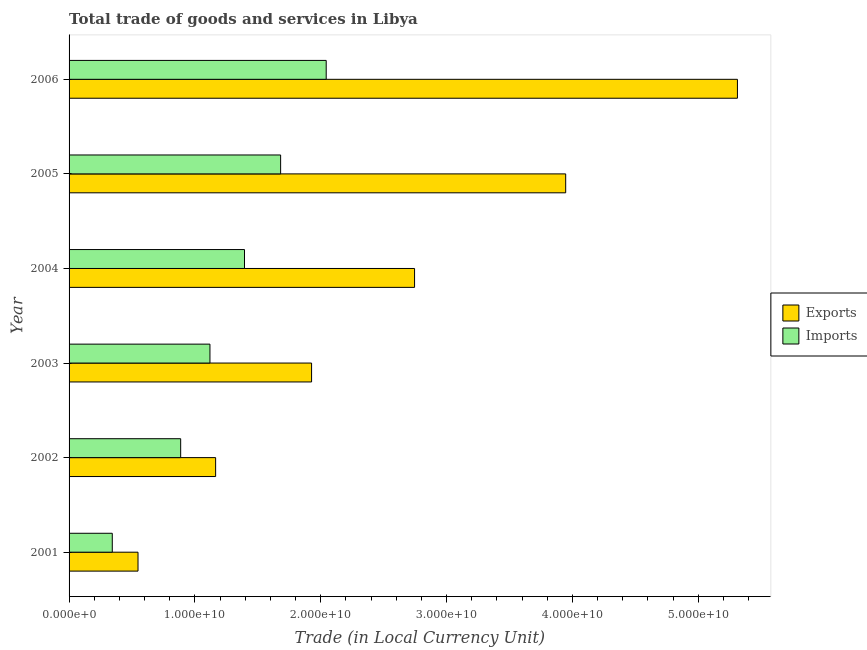How many different coloured bars are there?
Give a very brief answer. 2. Are the number of bars per tick equal to the number of legend labels?
Provide a succinct answer. Yes. How many bars are there on the 4th tick from the top?
Ensure brevity in your answer.  2. What is the label of the 1st group of bars from the top?
Keep it short and to the point. 2006. In how many cases, is the number of bars for a given year not equal to the number of legend labels?
Your response must be concise. 0. What is the export of goods and services in 2005?
Ensure brevity in your answer.  3.95e+1. Across all years, what is the maximum imports of goods and services?
Your response must be concise. 2.04e+1. Across all years, what is the minimum export of goods and services?
Make the answer very short. 5.48e+09. In which year was the imports of goods and services minimum?
Ensure brevity in your answer.  2001. What is the total export of goods and services in the graph?
Give a very brief answer. 1.56e+11. What is the difference between the export of goods and services in 2001 and that in 2006?
Provide a succinct answer. -4.76e+1. What is the difference between the imports of goods and services in 2006 and the export of goods and services in 2001?
Make the answer very short. 1.50e+1. What is the average export of goods and services per year?
Your answer should be compact. 2.61e+1. In the year 2004, what is the difference between the export of goods and services and imports of goods and services?
Provide a succinct answer. 1.35e+1. What is the ratio of the export of goods and services in 2001 to that in 2004?
Keep it short and to the point. 0.2. Is the export of goods and services in 2003 less than that in 2005?
Ensure brevity in your answer.  Yes. Is the difference between the imports of goods and services in 2003 and 2006 greater than the difference between the export of goods and services in 2003 and 2006?
Give a very brief answer. Yes. What is the difference between the highest and the second highest imports of goods and services?
Ensure brevity in your answer.  3.62e+09. What is the difference between the highest and the lowest export of goods and services?
Provide a succinct answer. 4.76e+1. Is the sum of the imports of goods and services in 2002 and 2003 greater than the maximum export of goods and services across all years?
Keep it short and to the point. No. What does the 2nd bar from the top in 2002 represents?
Provide a succinct answer. Exports. What does the 2nd bar from the bottom in 2002 represents?
Your answer should be very brief. Imports. How many years are there in the graph?
Provide a short and direct response. 6. Are the values on the major ticks of X-axis written in scientific E-notation?
Offer a very short reply. Yes. Does the graph contain any zero values?
Your answer should be very brief. No. Where does the legend appear in the graph?
Your response must be concise. Center right. How many legend labels are there?
Your answer should be very brief. 2. What is the title of the graph?
Ensure brevity in your answer.  Total trade of goods and services in Libya. Does "Males" appear as one of the legend labels in the graph?
Make the answer very short. No. What is the label or title of the X-axis?
Your answer should be very brief. Trade (in Local Currency Unit). What is the label or title of the Y-axis?
Provide a succinct answer. Year. What is the Trade (in Local Currency Unit) of Exports in 2001?
Make the answer very short. 5.48e+09. What is the Trade (in Local Currency Unit) in Imports in 2001?
Ensure brevity in your answer.  3.43e+09. What is the Trade (in Local Currency Unit) of Exports in 2002?
Keep it short and to the point. 1.16e+1. What is the Trade (in Local Currency Unit) of Imports in 2002?
Make the answer very short. 8.87e+09. What is the Trade (in Local Currency Unit) of Exports in 2003?
Ensure brevity in your answer.  1.93e+1. What is the Trade (in Local Currency Unit) of Imports in 2003?
Ensure brevity in your answer.  1.12e+1. What is the Trade (in Local Currency Unit) in Exports in 2004?
Your answer should be very brief. 2.75e+1. What is the Trade (in Local Currency Unit) of Imports in 2004?
Make the answer very short. 1.39e+1. What is the Trade (in Local Currency Unit) of Exports in 2005?
Keep it short and to the point. 3.95e+1. What is the Trade (in Local Currency Unit) in Imports in 2005?
Your answer should be very brief. 1.68e+1. What is the Trade (in Local Currency Unit) in Exports in 2006?
Your answer should be compact. 5.31e+1. What is the Trade (in Local Currency Unit) in Imports in 2006?
Your answer should be compact. 2.04e+1. Across all years, what is the maximum Trade (in Local Currency Unit) of Exports?
Keep it short and to the point. 5.31e+1. Across all years, what is the maximum Trade (in Local Currency Unit) in Imports?
Give a very brief answer. 2.04e+1. Across all years, what is the minimum Trade (in Local Currency Unit) in Exports?
Keep it short and to the point. 5.48e+09. Across all years, what is the minimum Trade (in Local Currency Unit) in Imports?
Your response must be concise. 3.43e+09. What is the total Trade (in Local Currency Unit) in Exports in the graph?
Provide a short and direct response. 1.56e+11. What is the total Trade (in Local Currency Unit) of Imports in the graph?
Give a very brief answer. 7.47e+1. What is the difference between the Trade (in Local Currency Unit) of Exports in 2001 and that in 2002?
Make the answer very short. -6.17e+09. What is the difference between the Trade (in Local Currency Unit) of Imports in 2001 and that in 2002?
Your response must be concise. -5.44e+09. What is the difference between the Trade (in Local Currency Unit) in Exports in 2001 and that in 2003?
Offer a very short reply. -1.38e+1. What is the difference between the Trade (in Local Currency Unit) of Imports in 2001 and that in 2003?
Ensure brevity in your answer.  -7.76e+09. What is the difference between the Trade (in Local Currency Unit) in Exports in 2001 and that in 2004?
Provide a short and direct response. -2.20e+1. What is the difference between the Trade (in Local Currency Unit) of Imports in 2001 and that in 2004?
Give a very brief answer. -1.05e+1. What is the difference between the Trade (in Local Currency Unit) in Exports in 2001 and that in 2005?
Ensure brevity in your answer.  -3.40e+1. What is the difference between the Trade (in Local Currency Unit) of Imports in 2001 and that in 2005?
Your answer should be compact. -1.34e+1. What is the difference between the Trade (in Local Currency Unit) in Exports in 2001 and that in 2006?
Your answer should be compact. -4.76e+1. What is the difference between the Trade (in Local Currency Unit) of Imports in 2001 and that in 2006?
Your answer should be compact. -1.70e+1. What is the difference between the Trade (in Local Currency Unit) of Exports in 2002 and that in 2003?
Keep it short and to the point. -7.62e+09. What is the difference between the Trade (in Local Currency Unit) of Imports in 2002 and that in 2003?
Offer a very short reply. -2.33e+09. What is the difference between the Trade (in Local Currency Unit) in Exports in 2002 and that in 2004?
Ensure brevity in your answer.  -1.58e+1. What is the difference between the Trade (in Local Currency Unit) in Imports in 2002 and that in 2004?
Offer a terse response. -5.07e+09. What is the difference between the Trade (in Local Currency Unit) in Exports in 2002 and that in 2005?
Offer a very short reply. -2.78e+1. What is the difference between the Trade (in Local Currency Unit) of Imports in 2002 and that in 2005?
Your answer should be compact. -7.94e+09. What is the difference between the Trade (in Local Currency Unit) of Exports in 2002 and that in 2006?
Your answer should be compact. -4.15e+1. What is the difference between the Trade (in Local Currency Unit) in Imports in 2002 and that in 2006?
Provide a short and direct response. -1.16e+1. What is the difference between the Trade (in Local Currency Unit) of Exports in 2003 and that in 2004?
Give a very brief answer. -8.18e+09. What is the difference between the Trade (in Local Currency Unit) of Imports in 2003 and that in 2004?
Provide a succinct answer. -2.75e+09. What is the difference between the Trade (in Local Currency Unit) of Exports in 2003 and that in 2005?
Offer a very short reply. -2.02e+1. What is the difference between the Trade (in Local Currency Unit) in Imports in 2003 and that in 2005?
Ensure brevity in your answer.  -5.62e+09. What is the difference between the Trade (in Local Currency Unit) in Exports in 2003 and that in 2006?
Your response must be concise. -3.38e+1. What is the difference between the Trade (in Local Currency Unit) in Imports in 2003 and that in 2006?
Give a very brief answer. -9.24e+09. What is the difference between the Trade (in Local Currency Unit) of Exports in 2004 and that in 2005?
Offer a very short reply. -1.20e+1. What is the difference between the Trade (in Local Currency Unit) of Imports in 2004 and that in 2005?
Keep it short and to the point. -2.87e+09. What is the difference between the Trade (in Local Currency Unit) in Exports in 2004 and that in 2006?
Provide a succinct answer. -2.57e+1. What is the difference between the Trade (in Local Currency Unit) of Imports in 2004 and that in 2006?
Make the answer very short. -6.49e+09. What is the difference between the Trade (in Local Currency Unit) in Exports in 2005 and that in 2006?
Your response must be concise. -1.36e+1. What is the difference between the Trade (in Local Currency Unit) in Imports in 2005 and that in 2006?
Provide a short and direct response. -3.62e+09. What is the difference between the Trade (in Local Currency Unit) of Exports in 2001 and the Trade (in Local Currency Unit) of Imports in 2002?
Make the answer very short. -3.39e+09. What is the difference between the Trade (in Local Currency Unit) of Exports in 2001 and the Trade (in Local Currency Unit) of Imports in 2003?
Provide a short and direct response. -5.72e+09. What is the difference between the Trade (in Local Currency Unit) of Exports in 2001 and the Trade (in Local Currency Unit) of Imports in 2004?
Your answer should be compact. -8.46e+09. What is the difference between the Trade (in Local Currency Unit) of Exports in 2001 and the Trade (in Local Currency Unit) of Imports in 2005?
Provide a succinct answer. -1.13e+1. What is the difference between the Trade (in Local Currency Unit) in Exports in 2001 and the Trade (in Local Currency Unit) in Imports in 2006?
Keep it short and to the point. -1.50e+1. What is the difference between the Trade (in Local Currency Unit) of Exports in 2002 and the Trade (in Local Currency Unit) of Imports in 2003?
Your response must be concise. 4.51e+08. What is the difference between the Trade (in Local Currency Unit) of Exports in 2002 and the Trade (in Local Currency Unit) of Imports in 2004?
Provide a succinct answer. -2.29e+09. What is the difference between the Trade (in Local Currency Unit) of Exports in 2002 and the Trade (in Local Currency Unit) of Imports in 2005?
Ensure brevity in your answer.  -5.17e+09. What is the difference between the Trade (in Local Currency Unit) of Exports in 2002 and the Trade (in Local Currency Unit) of Imports in 2006?
Your response must be concise. -8.79e+09. What is the difference between the Trade (in Local Currency Unit) in Exports in 2003 and the Trade (in Local Currency Unit) in Imports in 2004?
Keep it short and to the point. 5.33e+09. What is the difference between the Trade (in Local Currency Unit) in Exports in 2003 and the Trade (in Local Currency Unit) in Imports in 2005?
Your response must be concise. 2.46e+09. What is the difference between the Trade (in Local Currency Unit) in Exports in 2003 and the Trade (in Local Currency Unit) in Imports in 2006?
Offer a very short reply. -1.16e+09. What is the difference between the Trade (in Local Currency Unit) in Exports in 2004 and the Trade (in Local Currency Unit) in Imports in 2005?
Your answer should be compact. 1.06e+1. What is the difference between the Trade (in Local Currency Unit) in Exports in 2004 and the Trade (in Local Currency Unit) in Imports in 2006?
Provide a short and direct response. 7.02e+09. What is the difference between the Trade (in Local Currency Unit) of Exports in 2005 and the Trade (in Local Currency Unit) of Imports in 2006?
Ensure brevity in your answer.  1.90e+1. What is the average Trade (in Local Currency Unit) in Exports per year?
Give a very brief answer. 2.61e+1. What is the average Trade (in Local Currency Unit) in Imports per year?
Your response must be concise. 1.24e+1. In the year 2001, what is the difference between the Trade (in Local Currency Unit) in Exports and Trade (in Local Currency Unit) in Imports?
Your answer should be compact. 2.04e+09. In the year 2002, what is the difference between the Trade (in Local Currency Unit) in Exports and Trade (in Local Currency Unit) in Imports?
Your answer should be very brief. 2.78e+09. In the year 2003, what is the difference between the Trade (in Local Currency Unit) in Exports and Trade (in Local Currency Unit) in Imports?
Make the answer very short. 8.08e+09. In the year 2004, what is the difference between the Trade (in Local Currency Unit) in Exports and Trade (in Local Currency Unit) in Imports?
Your answer should be compact. 1.35e+1. In the year 2005, what is the difference between the Trade (in Local Currency Unit) in Exports and Trade (in Local Currency Unit) in Imports?
Keep it short and to the point. 2.27e+1. In the year 2006, what is the difference between the Trade (in Local Currency Unit) in Exports and Trade (in Local Currency Unit) in Imports?
Your answer should be compact. 3.27e+1. What is the ratio of the Trade (in Local Currency Unit) of Exports in 2001 to that in 2002?
Ensure brevity in your answer.  0.47. What is the ratio of the Trade (in Local Currency Unit) of Imports in 2001 to that in 2002?
Keep it short and to the point. 0.39. What is the ratio of the Trade (in Local Currency Unit) of Exports in 2001 to that in 2003?
Provide a short and direct response. 0.28. What is the ratio of the Trade (in Local Currency Unit) in Imports in 2001 to that in 2003?
Give a very brief answer. 0.31. What is the ratio of the Trade (in Local Currency Unit) in Exports in 2001 to that in 2004?
Provide a succinct answer. 0.2. What is the ratio of the Trade (in Local Currency Unit) in Imports in 2001 to that in 2004?
Provide a succinct answer. 0.25. What is the ratio of the Trade (in Local Currency Unit) of Exports in 2001 to that in 2005?
Offer a terse response. 0.14. What is the ratio of the Trade (in Local Currency Unit) in Imports in 2001 to that in 2005?
Give a very brief answer. 0.2. What is the ratio of the Trade (in Local Currency Unit) in Exports in 2001 to that in 2006?
Provide a succinct answer. 0.1. What is the ratio of the Trade (in Local Currency Unit) of Imports in 2001 to that in 2006?
Offer a very short reply. 0.17. What is the ratio of the Trade (in Local Currency Unit) of Exports in 2002 to that in 2003?
Make the answer very short. 0.6. What is the ratio of the Trade (in Local Currency Unit) of Imports in 2002 to that in 2003?
Keep it short and to the point. 0.79. What is the ratio of the Trade (in Local Currency Unit) in Exports in 2002 to that in 2004?
Offer a terse response. 0.42. What is the ratio of the Trade (in Local Currency Unit) of Imports in 2002 to that in 2004?
Your response must be concise. 0.64. What is the ratio of the Trade (in Local Currency Unit) of Exports in 2002 to that in 2005?
Keep it short and to the point. 0.3. What is the ratio of the Trade (in Local Currency Unit) of Imports in 2002 to that in 2005?
Your response must be concise. 0.53. What is the ratio of the Trade (in Local Currency Unit) of Exports in 2002 to that in 2006?
Keep it short and to the point. 0.22. What is the ratio of the Trade (in Local Currency Unit) of Imports in 2002 to that in 2006?
Provide a succinct answer. 0.43. What is the ratio of the Trade (in Local Currency Unit) of Exports in 2003 to that in 2004?
Keep it short and to the point. 0.7. What is the ratio of the Trade (in Local Currency Unit) of Imports in 2003 to that in 2004?
Your answer should be compact. 0.8. What is the ratio of the Trade (in Local Currency Unit) of Exports in 2003 to that in 2005?
Provide a short and direct response. 0.49. What is the ratio of the Trade (in Local Currency Unit) of Imports in 2003 to that in 2005?
Your response must be concise. 0.67. What is the ratio of the Trade (in Local Currency Unit) in Exports in 2003 to that in 2006?
Provide a succinct answer. 0.36. What is the ratio of the Trade (in Local Currency Unit) in Imports in 2003 to that in 2006?
Make the answer very short. 0.55. What is the ratio of the Trade (in Local Currency Unit) of Exports in 2004 to that in 2005?
Give a very brief answer. 0.7. What is the ratio of the Trade (in Local Currency Unit) in Imports in 2004 to that in 2005?
Your response must be concise. 0.83. What is the ratio of the Trade (in Local Currency Unit) of Exports in 2004 to that in 2006?
Your answer should be very brief. 0.52. What is the ratio of the Trade (in Local Currency Unit) of Imports in 2004 to that in 2006?
Your answer should be very brief. 0.68. What is the ratio of the Trade (in Local Currency Unit) in Exports in 2005 to that in 2006?
Provide a short and direct response. 0.74. What is the ratio of the Trade (in Local Currency Unit) of Imports in 2005 to that in 2006?
Ensure brevity in your answer.  0.82. What is the difference between the highest and the second highest Trade (in Local Currency Unit) of Exports?
Provide a succinct answer. 1.36e+1. What is the difference between the highest and the second highest Trade (in Local Currency Unit) of Imports?
Make the answer very short. 3.62e+09. What is the difference between the highest and the lowest Trade (in Local Currency Unit) of Exports?
Your response must be concise. 4.76e+1. What is the difference between the highest and the lowest Trade (in Local Currency Unit) in Imports?
Give a very brief answer. 1.70e+1. 